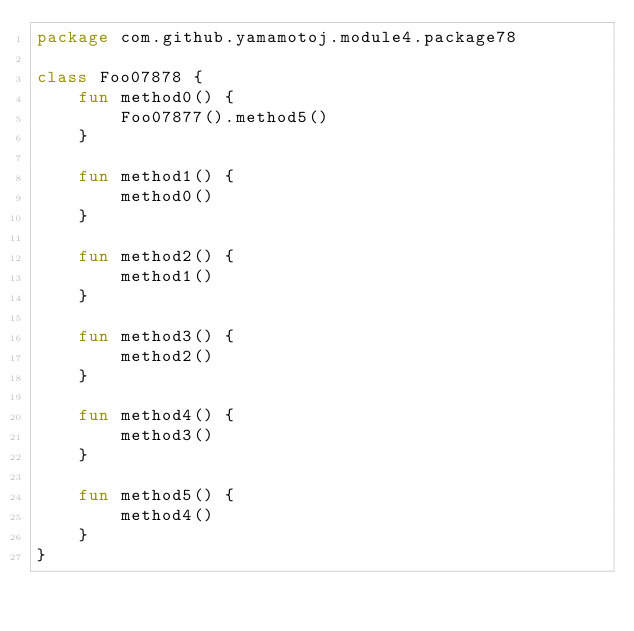<code> <loc_0><loc_0><loc_500><loc_500><_Kotlin_>package com.github.yamamotoj.module4.package78

class Foo07878 {
    fun method0() {
        Foo07877().method5()
    }

    fun method1() {
        method0()
    }

    fun method2() {
        method1()
    }

    fun method3() {
        method2()
    }

    fun method4() {
        method3()
    }

    fun method5() {
        method4()
    }
}
</code> 